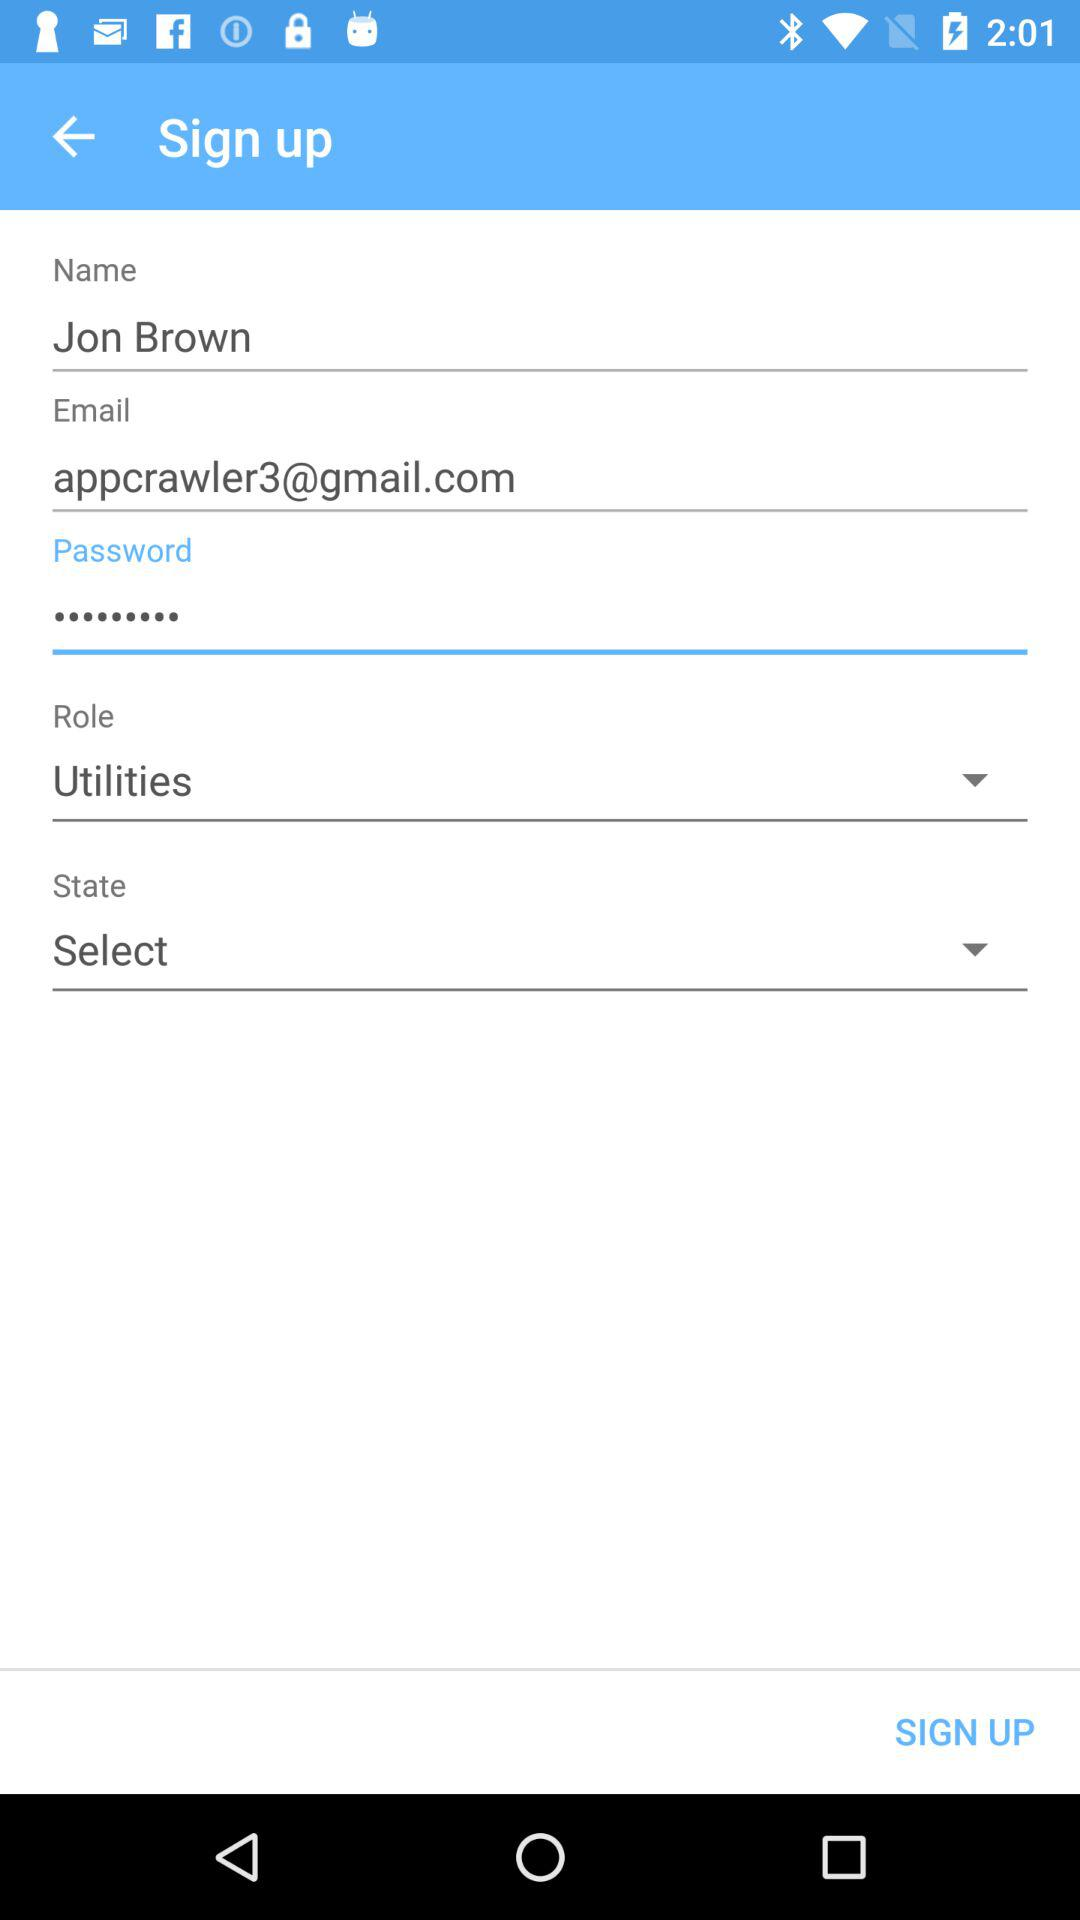What is the selected role? The selected role is "Utilities". 